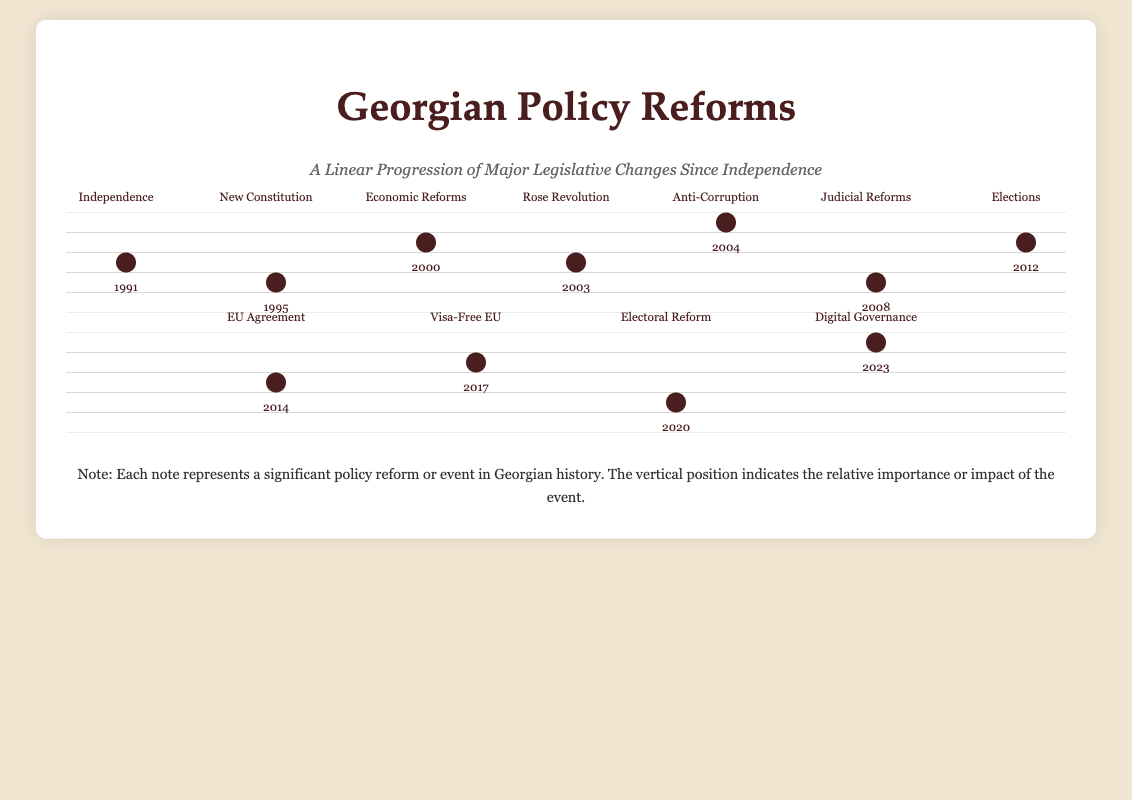What year did Georgia gain independence? The document indicates that Georgia gained independence in 1991.
Answer: 1991 What significant reform occurred in 2003? The document states that the Rose Revolution took place in 2003, which is significant in Georgia's legislative changes.
Answer: Rose Revolution Which agreement was made in 2014? In 2014, the document shows that Georgia signed an EU Agreement, marking a key policy reform.
Answer: EU Agreement What type of reform occurred in 2008? The document indicates that Judicial Reforms were introduced in 2008, highlighting a legislative change in that year.
Answer: Judicial Reforms What event coincided with the year 2020? The document shows that Electoral Reform occurred in 2020, relating to the political changes in Georgia.
Answer: Electoral Reform How many major reforms are noted in the timeline? Counting the events listed, there are a total of 11 major reforms and events noted in the document.
Answer: 11 What reform is associated with the year 2023? The document states that Digital Governance is the significant reform associated with the year 2023.
Answer: Digital Governance Which reform is placed highest on the staff? Looking at the staff positions, Anti-Corruption is depicted at the highest vertical placement, indicating its perceived significance.
Answer: Anti-Corruption What does the vertical position of a note indicate? The vertical position of a note on the staff in the document indicates the relative importance or impact of the event.
Answer: Importance or impact 